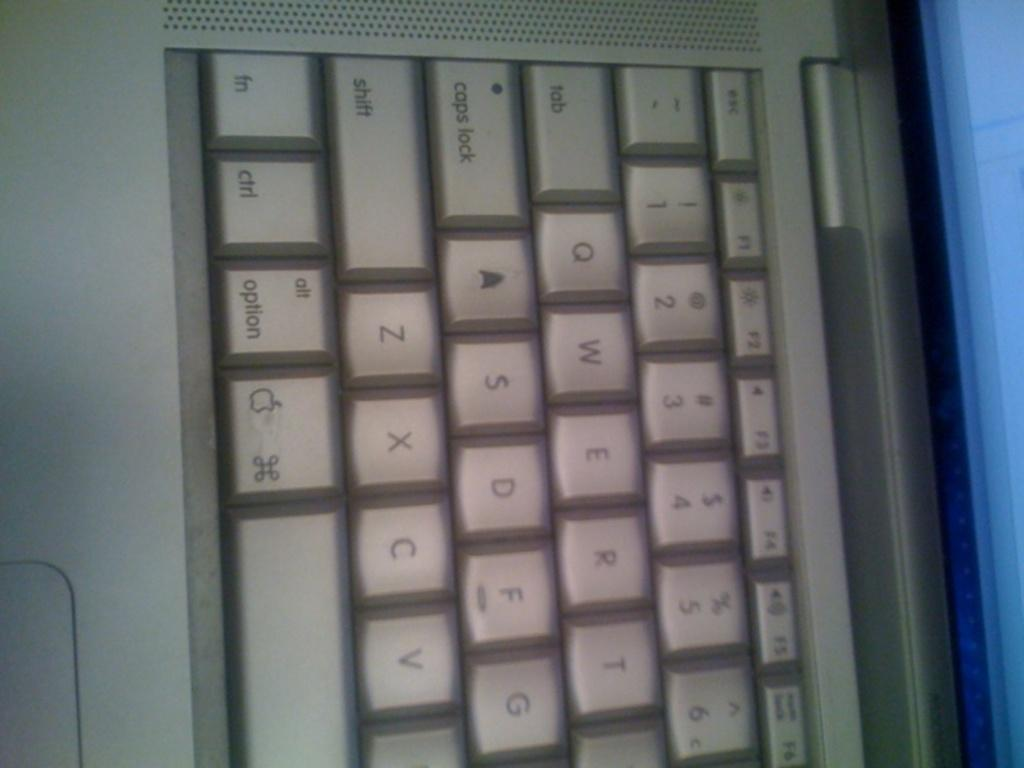Provide a one-sentence caption for the provided image. A closeup of an Apple keyboard showing buttons like caps lock and ctrl. 